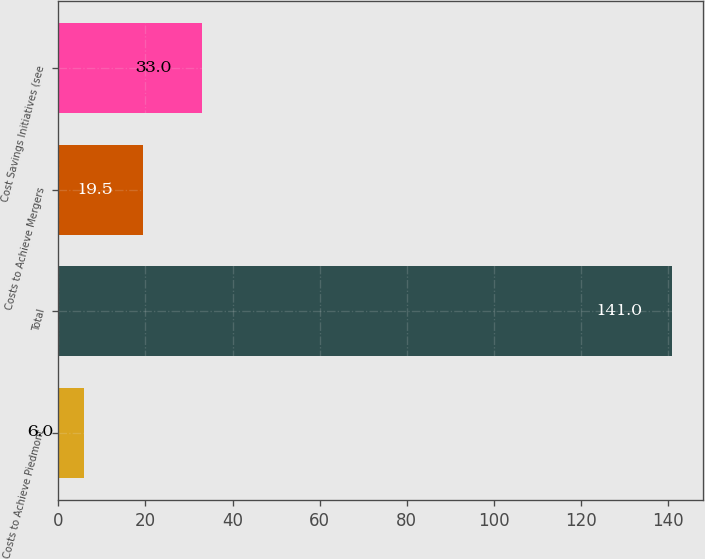<chart> <loc_0><loc_0><loc_500><loc_500><bar_chart><fcel>Costs to Achieve Piedmont<fcel>Total<fcel>Costs to Achieve Mergers<fcel>Cost Savings Initiatives (see<nl><fcel>6<fcel>141<fcel>19.5<fcel>33<nl></chart> 